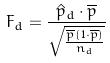<formula> <loc_0><loc_0><loc_500><loc_500>F _ { d } = \frac { \hat { p } _ { d } \cdot \overline { p } } { \sqrt { \frac { \overline { p } ( 1 \cdot \overline { p } ) } { n _ { d } } } }</formula> 